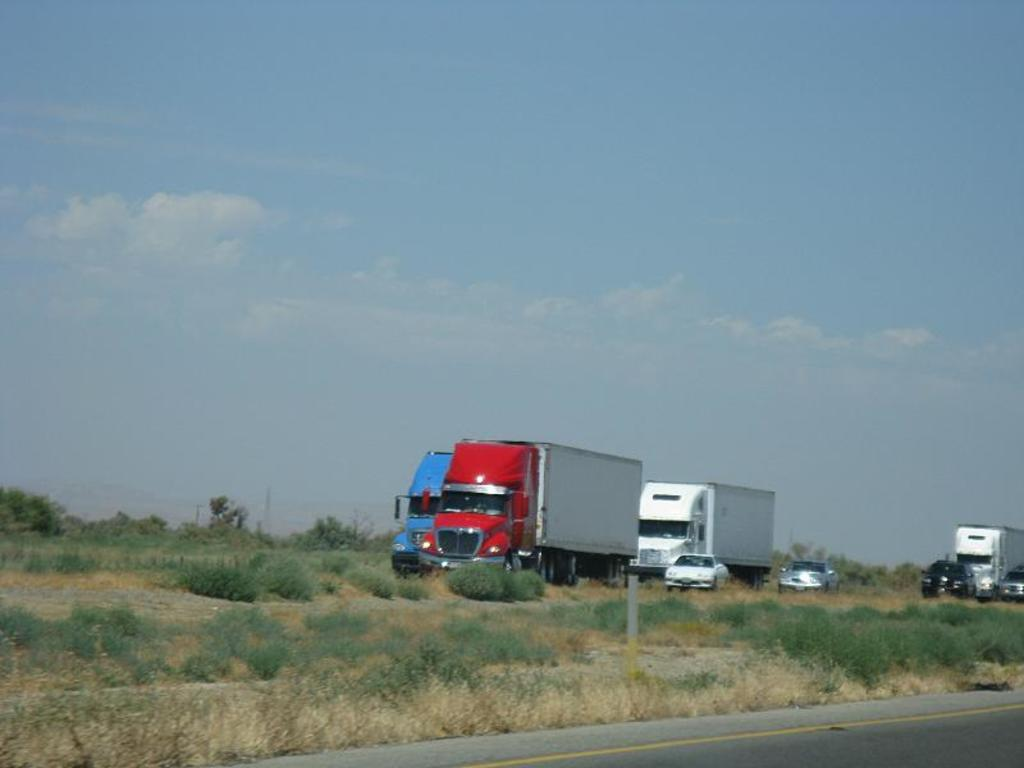What types of objects can be seen in the image? There are vehicles, plants, a pole, and trees in the image. What is the nature of the road in the image? The road has a yellow line at the bottom of the image. What can be seen in the background of the image? The sky is visible in the background of the image. Can you tell me how many grapes are hanging from the pole in the image? There are no grapes present in the image; the pole is not associated with any grapes. What type of bat is flying in the image? There are no bats present in the image; the image does not depict any flying creatures. 